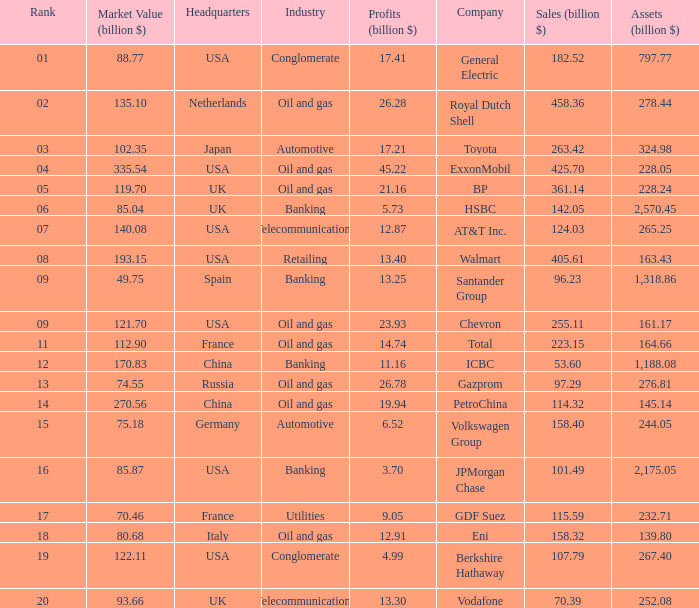How many Assets (billion $) has an Industry of oil and gas, and a Rank of 9, and a Market Value (billion $) larger than 121.7? None. 